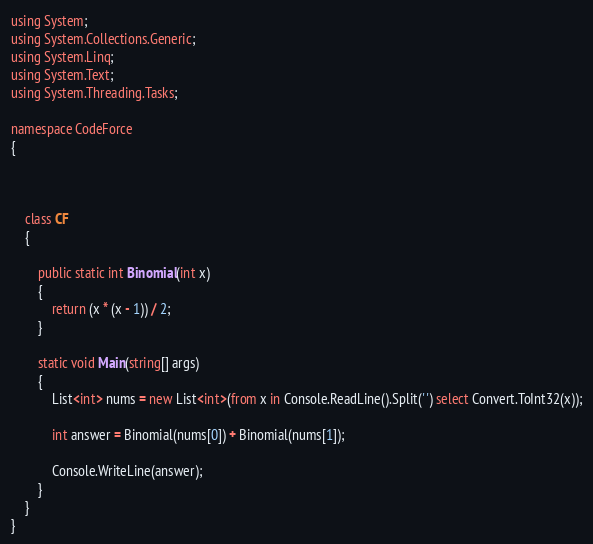Convert code to text. <code><loc_0><loc_0><loc_500><loc_500><_C#_>using System;
using System.Collections.Generic;
using System.Linq;
using System.Text;
using System.Threading.Tasks;

namespace CodeForce
{



    class CF
    {

        public static int Binomial(int x)
        {
            return (x * (x - 1)) / 2;
        }

        static void Main(string[] args)
        {
            List<int> nums = new List<int>(from x in Console.ReadLine().Split(' ') select Convert.ToInt32(x));

            int answer = Binomial(nums[0]) + Binomial(nums[1]);

            Console.WriteLine(answer);
        }
    }
}</code> 